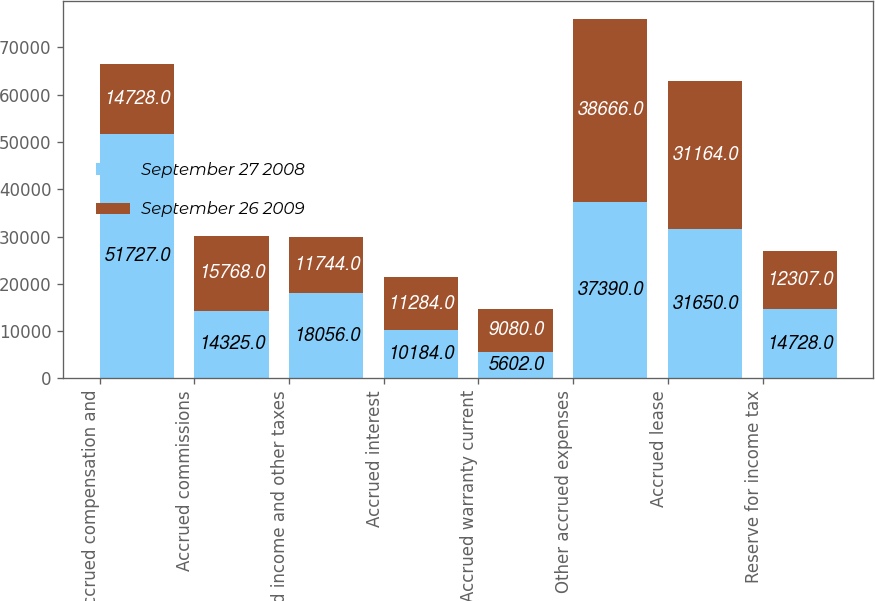<chart> <loc_0><loc_0><loc_500><loc_500><stacked_bar_chart><ecel><fcel>Accrued compensation and<fcel>Accrued commissions<fcel>Accrued income and other taxes<fcel>Accrued interest<fcel>Accrued warranty current<fcel>Other accrued expenses<fcel>Accrued lease<fcel>Reserve for income tax<nl><fcel>September 27 2008<fcel>51727<fcel>14325<fcel>18056<fcel>10184<fcel>5602<fcel>37390<fcel>31650<fcel>14728<nl><fcel>September 26 2009<fcel>14728<fcel>15768<fcel>11744<fcel>11284<fcel>9080<fcel>38666<fcel>31164<fcel>12307<nl></chart> 